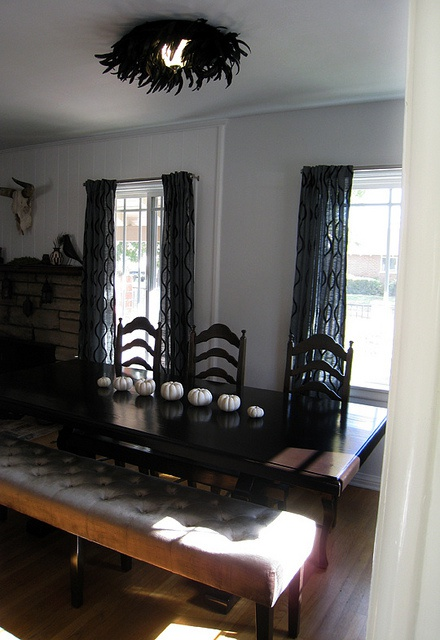Describe the objects in this image and their specific colors. I can see bench in gray, black, maroon, and white tones, dining table in gray, black, white, and darkgray tones, chair in gray, black, navy, and white tones, chair in gray and black tones, and chair in gray, black, white, and darkgray tones in this image. 